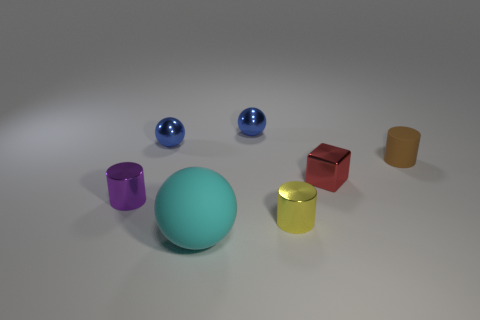Add 3 small blue cylinders. How many objects exist? 10 Subtract all tiny metal cylinders. How many cylinders are left? 1 Subtract all blue spheres. How many spheres are left? 1 Subtract 0 red cylinders. How many objects are left? 7 Subtract all cubes. How many objects are left? 6 Subtract 1 cubes. How many cubes are left? 0 Subtract all purple balls. Subtract all gray cubes. How many balls are left? 3 Subtract all red spheres. How many green blocks are left? 0 Subtract all red blocks. Subtract all small blue things. How many objects are left? 4 Add 3 cyan rubber balls. How many cyan rubber balls are left? 4 